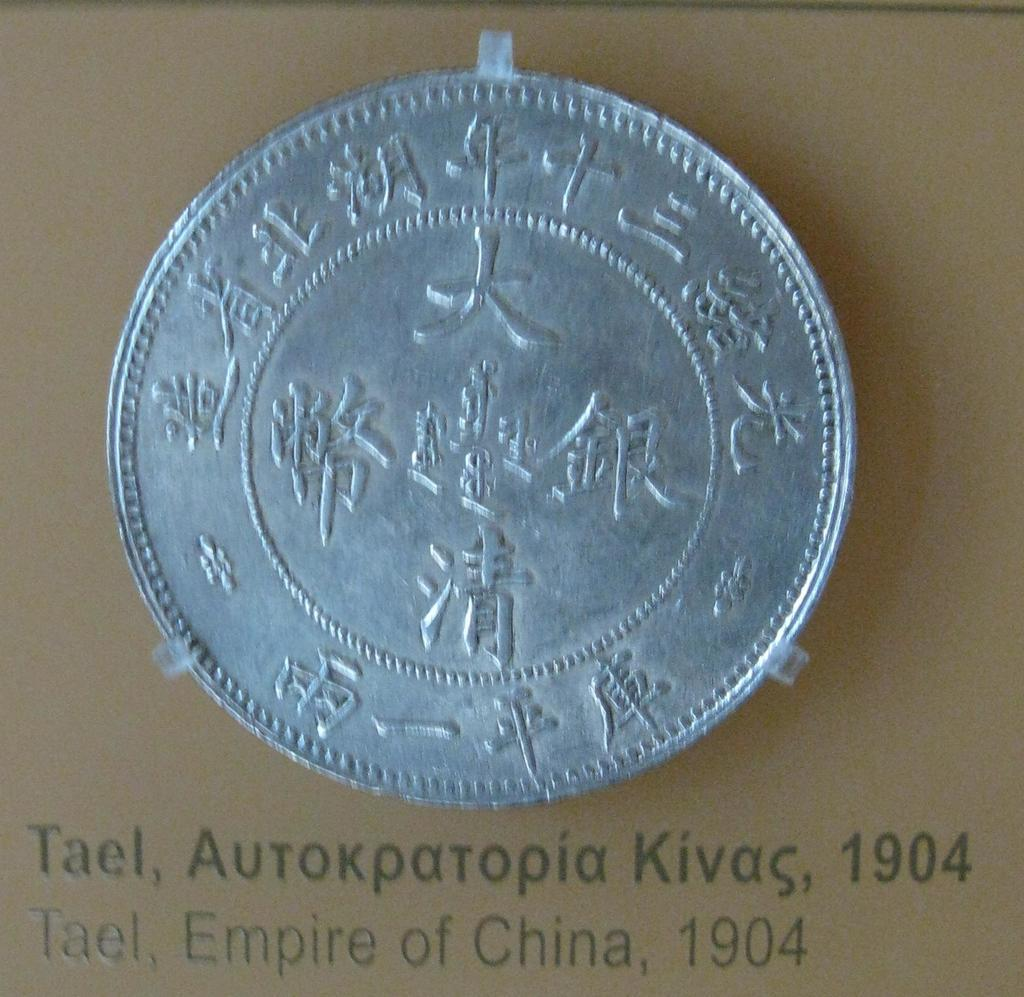<image>
Share a concise interpretation of the image provided. a silver coin above words that say 'tael, autokpatopia kivas, 1904' 